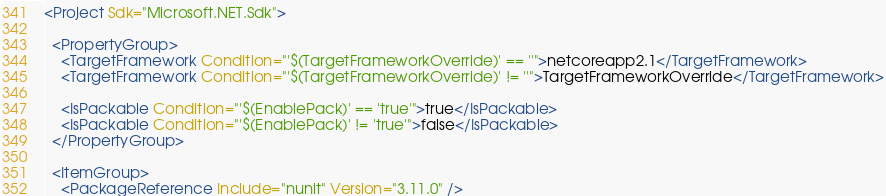<code> <loc_0><loc_0><loc_500><loc_500><_XML_><Project Sdk="Microsoft.NET.Sdk">

  <PropertyGroup>
    <TargetFramework Condition="'$(TargetFrameworkOverride)' == ''">netcoreapp2.1</TargetFramework>
    <TargetFramework Condition="'$(TargetFrameworkOverride)' != ''">TargetFrameworkOverride</TargetFramework>

    <IsPackable Condition="'$(EnablePack)' == 'true'">true</IsPackable>
    <IsPackable Condition="'$(EnablePack)' != 'true'">false</IsPackable>
  </PropertyGroup>

  <ItemGroup>
    <PackageReference Include="nunit" Version="3.11.0" /></code> 